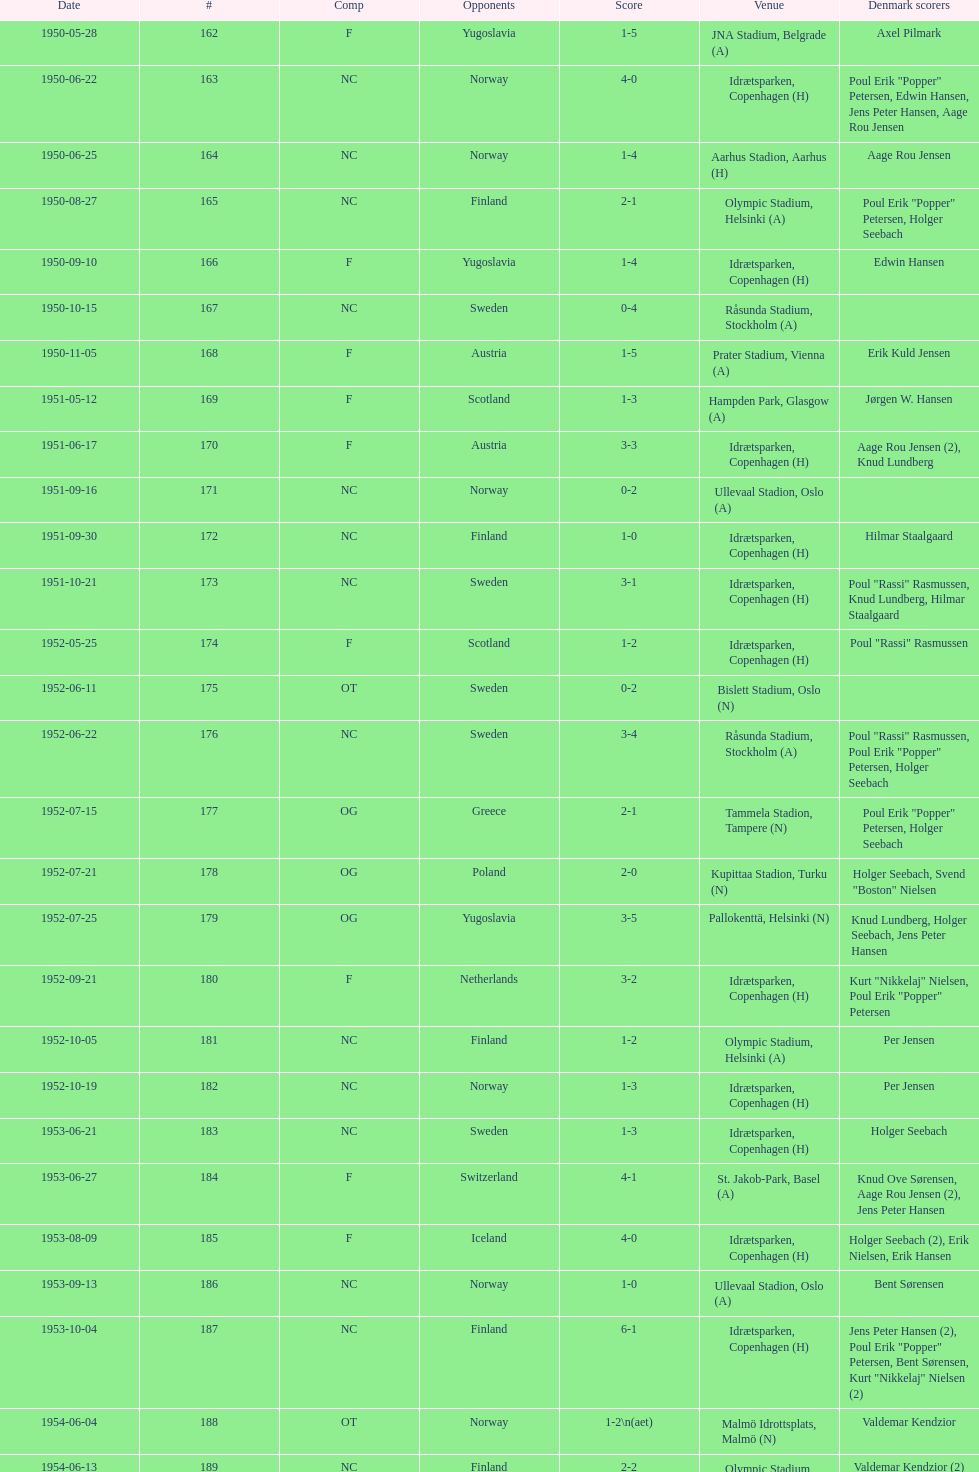What was the difference in score between the two teams in the last game? 1. 